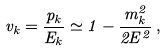Convert formula to latex. <formula><loc_0><loc_0><loc_500><loc_500>v _ { k } = \frac { p _ { k } } { E _ { k } } \simeq 1 - \frac { m _ { k } ^ { 2 } } { 2 E ^ { 2 } } \, ,</formula> 